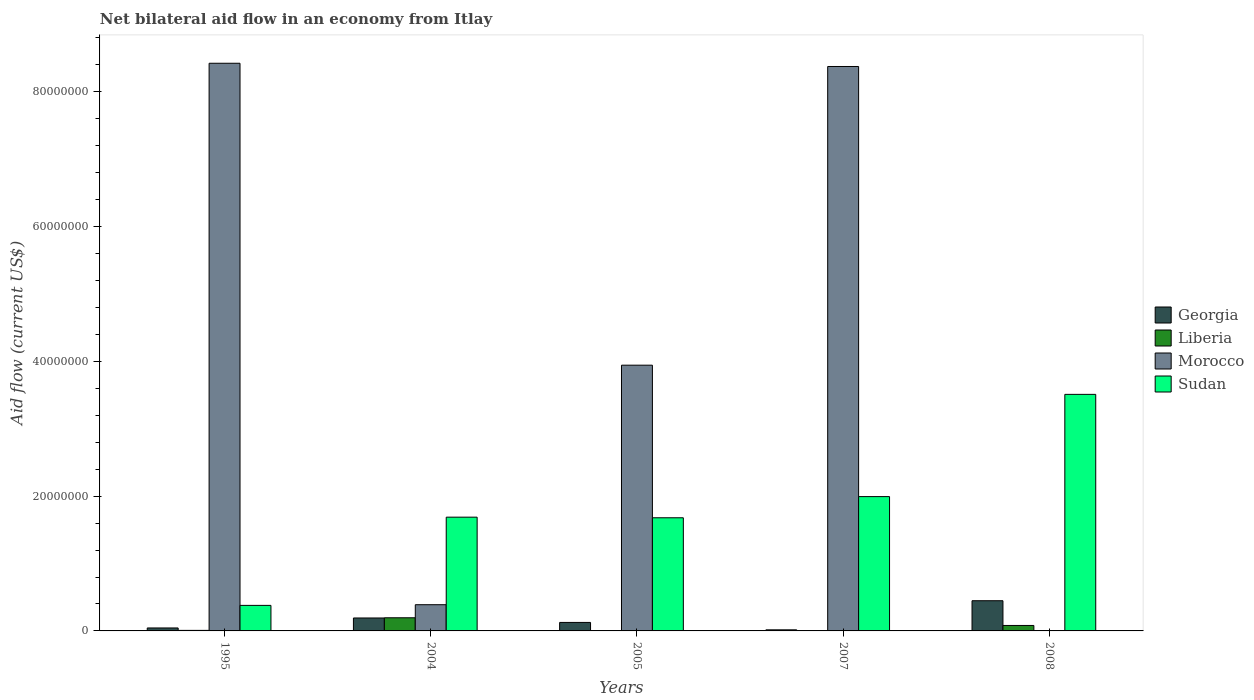How many different coloured bars are there?
Offer a terse response. 4. In how many cases, is the number of bars for a given year not equal to the number of legend labels?
Your response must be concise. 1. What is the net bilateral aid flow in Sudan in 2005?
Make the answer very short. 1.68e+07. Across all years, what is the maximum net bilateral aid flow in Liberia?
Provide a succinct answer. 1.95e+06. In which year was the net bilateral aid flow in Sudan maximum?
Offer a terse response. 2008. What is the total net bilateral aid flow in Georgia in the graph?
Your response must be concise. 8.26e+06. What is the difference between the net bilateral aid flow in Georgia in 2007 and that in 2008?
Your response must be concise. -4.32e+06. What is the difference between the net bilateral aid flow in Liberia in 2007 and the net bilateral aid flow in Morocco in 2005?
Keep it short and to the point. -3.94e+07. What is the average net bilateral aid flow in Sudan per year?
Your answer should be compact. 1.85e+07. In the year 2005, what is the difference between the net bilateral aid flow in Georgia and net bilateral aid flow in Liberia?
Your answer should be very brief. 1.24e+06. What is the ratio of the net bilateral aid flow in Sudan in 1995 to that in 2005?
Your response must be concise. 0.23. Is the net bilateral aid flow in Liberia in 1995 less than that in 2007?
Give a very brief answer. No. What is the difference between the highest and the second highest net bilateral aid flow in Liberia?
Make the answer very short. 1.14e+06. What is the difference between the highest and the lowest net bilateral aid flow in Morocco?
Provide a short and direct response. 8.42e+07. How many bars are there?
Your answer should be very brief. 19. Does the graph contain any zero values?
Ensure brevity in your answer.  Yes. How many legend labels are there?
Your answer should be very brief. 4. How are the legend labels stacked?
Offer a very short reply. Vertical. What is the title of the graph?
Give a very brief answer. Net bilateral aid flow in an economy from Itlay. Does "Small states" appear as one of the legend labels in the graph?
Provide a succinct answer. No. What is the label or title of the X-axis?
Offer a terse response. Years. What is the label or title of the Y-axis?
Give a very brief answer. Aid flow (current US$). What is the Aid flow (current US$) of Morocco in 1995?
Provide a short and direct response. 8.42e+07. What is the Aid flow (current US$) in Sudan in 1995?
Ensure brevity in your answer.  3.79e+06. What is the Aid flow (current US$) of Georgia in 2004?
Offer a very short reply. 1.92e+06. What is the Aid flow (current US$) in Liberia in 2004?
Provide a succinct answer. 1.95e+06. What is the Aid flow (current US$) of Morocco in 2004?
Keep it short and to the point. 3.89e+06. What is the Aid flow (current US$) in Sudan in 2004?
Offer a terse response. 1.69e+07. What is the Aid flow (current US$) of Georgia in 2005?
Give a very brief answer. 1.26e+06. What is the Aid flow (current US$) of Liberia in 2005?
Your answer should be very brief. 2.00e+04. What is the Aid flow (current US$) of Morocco in 2005?
Keep it short and to the point. 3.94e+07. What is the Aid flow (current US$) of Sudan in 2005?
Provide a short and direct response. 1.68e+07. What is the Aid flow (current US$) of Morocco in 2007?
Offer a very short reply. 8.38e+07. What is the Aid flow (current US$) of Sudan in 2007?
Provide a short and direct response. 1.99e+07. What is the Aid flow (current US$) in Georgia in 2008?
Provide a succinct answer. 4.48e+06. What is the Aid flow (current US$) in Liberia in 2008?
Give a very brief answer. 8.10e+05. What is the Aid flow (current US$) of Sudan in 2008?
Make the answer very short. 3.51e+07. Across all years, what is the maximum Aid flow (current US$) in Georgia?
Your answer should be very brief. 4.48e+06. Across all years, what is the maximum Aid flow (current US$) in Liberia?
Make the answer very short. 1.95e+06. Across all years, what is the maximum Aid flow (current US$) in Morocco?
Keep it short and to the point. 8.42e+07. Across all years, what is the maximum Aid flow (current US$) of Sudan?
Your answer should be compact. 3.51e+07. Across all years, what is the minimum Aid flow (current US$) of Georgia?
Provide a short and direct response. 1.60e+05. Across all years, what is the minimum Aid flow (current US$) of Sudan?
Make the answer very short. 3.79e+06. What is the total Aid flow (current US$) in Georgia in the graph?
Offer a terse response. 8.26e+06. What is the total Aid flow (current US$) in Liberia in the graph?
Provide a succinct answer. 2.87e+06. What is the total Aid flow (current US$) of Morocco in the graph?
Ensure brevity in your answer.  2.11e+08. What is the total Aid flow (current US$) of Sudan in the graph?
Your answer should be very brief. 9.25e+07. What is the difference between the Aid flow (current US$) of Georgia in 1995 and that in 2004?
Ensure brevity in your answer.  -1.48e+06. What is the difference between the Aid flow (current US$) in Liberia in 1995 and that in 2004?
Keep it short and to the point. -1.87e+06. What is the difference between the Aid flow (current US$) in Morocco in 1995 and that in 2004?
Your answer should be very brief. 8.03e+07. What is the difference between the Aid flow (current US$) in Sudan in 1995 and that in 2004?
Offer a very short reply. -1.31e+07. What is the difference between the Aid flow (current US$) of Georgia in 1995 and that in 2005?
Give a very brief answer. -8.20e+05. What is the difference between the Aid flow (current US$) in Morocco in 1995 and that in 2005?
Your response must be concise. 4.48e+07. What is the difference between the Aid flow (current US$) in Sudan in 1995 and that in 2005?
Offer a terse response. -1.30e+07. What is the difference between the Aid flow (current US$) of Liberia in 1995 and that in 2007?
Ensure brevity in your answer.  7.00e+04. What is the difference between the Aid flow (current US$) of Sudan in 1995 and that in 2007?
Keep it short and to the point. -1.61e+07. What is the difference between the Aid flow (current US$) in Georgia in 1995 and that in 2008?
Keep it short and to the point. -4.04e+06. What is the difference between the Aid flow (current US$) in Liberia in 1995 and that in 2008?
Keep it short and to the point. -7.30e+05. What is the difference between the Aid flow (current US$) in Sudan in 1995 and that in 2008?
Provide a short and direct response. -3.13e+07. What is the difference between the Aid flow (current US$) in Georgia in 2004 and that in 2005?
Your answer should be very brief. 6.60e+05. What is the difference between the Aid flow (current US$) of Liberia in 2004 and that in 2005?
Give a very brief answer. 1.93e+06. What is the difference between the Aid flow (current US$) of Morocco in 2004 and that in 2005?
Your answer should be very brief. -3.55e+07. What is the difference between the Aid flow (current US$) of Sudan in 2004 and that in 2005?
Provide a succinct answer. 9.00e+04. What is the difference between the Aid flow (current US$) of Georgia in 2004 and that in 2007?
Provide a short and direct response. 1.76e+06. What is the difference between the Aid flow (current US$) of Liberia in 2004 and that in 2007?
Offer a terse response. 1.94e+06. What is the difference between the Aid flow (current US$) in Morocco in 2004 and that in 2007?
Offer a terse response. -7.99e+07. What is the difference between the Aid flow (current US$) of Sudan in 2004 and that in 2007?
Provide a short and direct response. -3.05e+06. What is the difference between the Aid flow (current US$) in Georgia in 2004 and that in 2008?
Provide a succinct answer. -2.56e+06. What is the difference between the Aid flow (current US$) in Liberia in 2004 and that in 2008?
Ensure brevity in your answer.  1.14e+06. What is the difference between the Aid flow (current US$) in Sudan in 2004 and that in 2008?
Make the answer very short. -1.82e+07. What is the difference between the Aid flow (current US$) in Georgia in 2005 and that in 2007?
Your answer should be compact. 1.10e+06. What is the difference between the Aid flow (current US$) in Liberia in 2005 and that in 2007?
Ensure brevity in your answer.  10000. What is the difference between the Aid flow (current US$) in Morocco in 2005 and that in 2007?
Keep it short and to the point. -4.43e+07. What is the difference between the Aid flow (current US$) in Sudan in 2005 and that in 2007?
Your response must be concise. -3.14e+06. What is the difference between the Aid flow (current US$) in Georgia in 2005 and that in 2008?
Keep it short and to the point. -3.22e+06. What is the difference between the Aid flow (current US$) of Liberia in 2005 and that in 2008?
Provide a short and direct response. -7.90e+05. What is the difference between the Aid flow (current US$) in Sudan in 2005 and that in 2008?
Provide a succinct answer. -1.83e+07. What is the difference between the Aid flow (current US$) in Georgia in 2007 and that in 2008?
Provide a short and direct response. -4.32e+06. What is the difference between the Aid flow (current US$) in Liberia in 2007 and that in 2008?
Make the answer very short. -8.00e+05. What is the difference between the Aid flow (current US$) in Sudan in 2007 and that in 2008?
Provide a succinct answer. -1.52e+07. What is the difference between the Aid flow (current US$) of Georgia in 1995 and the Aid flow (current US$) of Liberia in 2004?
Your answer should be very brief. -1.51e+06. What is the difference between the Aid flow (current US$) in Georgia in 1995 and the Aid flow (current US$) in Morocco in 2004?
Offer a terse response. -3.45e+06. What is the difference between the Aid flow (current US$) of Georgia in 1995 and the Aid flow (current US$) of Sudan in 2004?
Give a very brief answer. -1.64e+07. What is the difference between the Aid flow (current US$) in Liberia in 1995 and the Aid flow (current US$) in Morocco in 2004?
Offer a terse response. -3.81e+06. What is the difference between the Aid flow (current US$) of Liberia in 1995 and the Aid flow (current US$) of Sudan in 2004?
Offer a very short reply. -1.68e+07. What is the difference between the Aid flow (current US$) of Morocco in 1995 and the Aid flow (current US$) of Sudan in 2004?
Your response must be concise. 6.74e+07. What is the difference between the Aid flow (current US$) in Georgia in 1995 and the Aid flow (current US$) in Liberia in 2005?
Your answer should be very brief. 4.20e+05. What is the difference between the Aid flow (current US$) in Georgia in 1995 and the Aid flow (current US$) in Morocco in 2005?
Provide a succinct answer. -3.90e+07. What is the difference between the Aid flow (current US$) in Georgia in 1995 and the Aid flow (current US$) in Sudan in 2005?
Keep it short and to the point. -1.64e+07. What is the difference between the Aid flow (current US$) of Liberia in 1995 and the Aid flow (current US$) of Morocco in 2005?
Make the answer very short. -3.94e+07. What is the difference between the Aid flow (current US$) in Liberia in 1995 and the Aid flow (current US$) in Sudan in 2005?
Give a very brief answer. -1.67e+07. What is the difference between the Aid flow (current US$) of Morocco in 1995 and the Aid flow (current US$) of Sudan in 2005?
Your answer should be compact. 6.74e+07. What is the difference between the Aid flow (current US$) of Georgia in 1995 and the Aid flow (current US$) of Liberia in 2007?
Keep it short and to the point. 4.30e+05. What is the difference between the Aid flow (current US$) in Georgia in 1995 and the Aid flow (current US$) in Morocco in 2007?
Your response must be concise. -8.33e+07. What is the difference between the Aid flow (current US$) in Georgia in 1995 and the Aid flow (current US$) in Sudan in 2007?
Your answer should be compact. -1.95e+07. What is the difference between the Aid flow (current US$) of Liberia in 1995 and the Aid flow (current US$) of Morocco in 2007?
Your answer should be very brief. -8.37e+07. What is the difference between the Aid flow (current US$) in Liberia in 1995 and the Aid flow (current US$) in Sudan in 2007?
Offer a very short reply. -1.98e+07. What is the difference between the Aid flow (current US$) in Morocco in 1995 and the Aid flow (current US$) in Sudan in 2007?
Offer a very short reply. 6.43e+07. What is the difference between the Aid flow (current US$) in Georgia in 1995 and the Aid flow (current US$) in Liberia in 2008?
Offer a very short reply. -3.70e+05. What is the difference between the Aid flow (current US$) of Georgia in 1995 and the Aid flow (current US$) of Sudan in 2008?
Keep it short and to the point. -3.47e+07. What is the difference between the Aid flow (current US$) of Liberia in 1995 and the Aid flow (current US$) of Sudan in 2008?
Offer a terse response. -3.50e+07. What is the difference between the Aid flow (current US$) of Morocco in 1995 and the Aid flow (current US$) of Sudan in 2008?
Your answer should be compact. 4.91e+07. What is the difference between the Aid flow (current US$) in Georgia in 2004 and the Aid flow (current US$) in Liberia in 2005?
Keep it short and to the point. 1.90e+06. What is the difference between the Aid flow (current US$) of Georgia in 2004 and the Aid flow (current US$) of Morocco in 2005?
Provide a short and direct response. -3.75e+07. What is the difference between the Aid flow (current US$) in Georgia in 2004 and the Aid flow (current US$) in Sudan in 2005?
Provide a succinct answer. -1.49e+07. What is the difference between the Aid flow (current US$) of Liberia in 2004 and the Aid flow (current US$) of Morocco in 2005?
Your answer should be compact. -3.75e+07. What is the difference between the Aid flow (current US$) of Liberia in 2004 and the Aid flow (current US$) of Sudan in 2005?
Offer a terse response. -1.48e+07. What is the difference between the Aid flow (current US$) in Morocco in 2004 and the Aid flow (current US$) in Sudan in 2005?
Offer a very short reply. -1.29e+07. What is the difference between the Aid flow (current US$) of Georgia in 2004 and the Aid flow (current US$) of Liberia in 2007?
Your answer should be very brief. 1.91e+06. What is the difference between the Aid flow (current US$) in Georgia in 2004 and the Aid flow (current US$) in Morocco in 2007?
Your answer should be compact. -8.18e+07. What is the difference between the Aid flow (current US$) in Georgia in 2004 and the Aid flow (current US$) in Sudan in 2007?
Your answer should be compact. -1.80e+07. What is the difference between the Aid flow (current US$) of Liberia in 2004 and the Aid flow (current US$) of Morocco in 2007?
Your answer should be very brief. -8.18e+07. What is the difference between the Aid flow (current US$) in Liberia in 2004 and the Aid flow (current US$) in Sudan in 2007?
Give a very brief answer. -1.80e+07. What is the difference between the Aid flow (current US$) in Morocco in 2004 and the Aid flow (current US$) in Sudan in 2007?
Give a very brief answer. -1.60e+07. What is the difference between the Aid flow (current US$) in Georgia in 2004 and the Aid flow (current US$) in Liberia in 2008?
Offer a very short reply. 1.11e+06. What is the difference between the Aid flow (current US$) in Georgia in 2004 and the Aid flow (current US$) in Sudan in 2008?
Your response must be concise. -3.32e+07. What is the difference between the Aid flow (current US$) in Liberia in 2004 and the Aid flow (current US$) in Sudan in 2008?
Offer a very short reply. -3.32e+07. What is the difference between the Aid flow (current US$) of Morocco in 2004 and the Aid flow (current US$) of Sudan in 2008?
Your answer should be very brief. -3.12e+07. What is the difference between the Aid flow (current US$) in Georgia in 2005 and the Aid flow (current US$) in Liberia in 2007?
Offer a very short reply. 1.25e+06. What is the difference between the Aid flow (current US$) in Georgia in 2005 and the Aid flow (current US$) in Morocco in 2007?
Your answer should be compact. -8.25e+07. What is the difference between the Aid flow (current US$) in Georgia in 2005 and the Aid flow (current US$) in Sudan in 2007?
Offer a very short reply. -1.87e+07. What is the difference between the Aid flow (current US$) of Liberia in 2005 and the Aid flow (current US$) of Morocco in 2007?
Ensure brevity in your answer.  -8.37e+07. What is the difference between the Aid flow (current US$) of Liberia in 2005 and the Aid flow (current US$) of Sudan in 2007?
Offer a very short reply. -1.99e+07. What is the difference between the Aid flow (current US$) in Morocco in 2005 and the Aid flow (current US$) in Sudan in 2007?
Your answer should be compact. 1.95e+07. What is the difference between the Aid flow (current US$) in Georgia in 2005 and the Aid flow (current US$) in Sudan in 2008?
Provide a succinct answer. -3.38e+07. What is the difference between the Aid flow (current US$) in Liberia in 2005 and the Aid flow (current US$) in Sudan in 2008?
Offer a terse response. -3.51e+07. What is the difference between the Aid flow (current US$) of Morocco in 2005 and the Aid flow (current US$) of Sudan in 2008?
Make the answer very short. 4.33e+06. What is the difference between the Aid flow (current US$) in Georgia in 2007 and the Aid flow (current US$) in Liberia in 2008?
Provide a succinct answer. -6.50e+05. What is the difference between the Aid flow (current US$) in Georgia in 2007 and the Aid flow (current US$) in Sudan in 2008?
Give a very brief answer. -3.49e+07. What is the difference between the Aid flow (current US$) in Liberia in 2007 and the Aid flow (current US$) in Sudan in 2008?
Your response must be concise. -3.51e+07. What is the difference between the Aid flow (current US$) in Morocco in 2007 and the Aid flow (current US$) in Sudan in 2008?
Keep it short and to the point. 4.86e+07. What is the average Aid flow (current US$) of Georgia per year?
Give a very brief answer. 1.65e+06. What is the average Aid flow (current US$) in Liberia per year?
Ensure brevity in your answer.  5.74e+05. What is the average Aid flow (current US$) in Morocco per year?
Your response must be concise. 4.23e+07. What is the average Aid flow (current US$) in Sudan per year?
Provide a short and direct response. 1.85e+07. In the year 1995, what is the difference between the Aid flow (current US$) in Georgia and Aid flow (current US$) in Morocco?
Provide a short and direct response. -8.38e+07. In the year 1995, what is the difference between the Aid flow (current US$) in Georgia and Aid flow (current US$) in Sudan?
Give a very brief answer. -3.35e+06. In the year 1995, what is the difference between the Aid flow (current US$) in Liberia and Aid flow (current US$) in Morocco?
Give a very brief answer. -8.42e+07. In the year 1995, what is the difference between the Aid flow (current US$) of Liberia and Aid flow (current US$) of Sudan?
Provide a short and direct response. -3.71e+06. In the year 1995, what is the difference between the Aid flow (current US$) of Morocco and Aid flow (current US$) of Sudan?
Your response must be concise. 8.04e+07. In the year 2004, what is the difference between the Aid flow (current US$) in Georgia and Aid flow (current US$) in Liberia?
Make the answer very short. -3.00e+04. In the year 2004, what is the difference between the Aid flow (current US$) in Georgia and Aid flow (current US$) in Morocco?
Provide a succinct answer. -1.97e+06. In the year 2004, what is the difference between the Aid flow (current US$) in Georgia and Aid flow (current US$) in Sudan?
Ensure brevity in your answer.  -1.50e+07. In the year 2004, what is the difference between the Aid flow (current US$) in Liberia and Aid flow (current US$) in Morocco?
Give a very brief answer. -1.94e+06. In the year 2004, what is the difference between the Aid flow (current US$) in Liberia and Aid flow (current US$) in Sudan?
Give a very brief answer. -1.49e+07. In the year 2004, what is the difference between the Aid flow (current US$) of Morocco and Aid flow (current US$) of Sudan?
Your answer should be very brief. -1.30e+07. In the year 2005, what is the difference between the Aid flow (current US$) of Georgia and Aid flow (current US$) of Liberia?
Offer a very short reply. 1.24e+06. In the year 2005, what is the difference between the Aid flow (current US$) in Georgia and Aid flow (current US$) in Morocco?
Keep it short and to the point. -3.82e+07. In the year 2005, what is the difference between the Aid flow (current US$) of Georgia and Aid flow (current US$) of Sudan?
Offer a terse response. -1.55e+07. In the year 2005, what is the difference between the Aid flow (current US$) of Liberia and Aid flow (current US$) of Morocco?
Offer a very short reply. -3.94e+07. In the year 2005, what is the difference between the Aid flow (current US$) in Liberia and Aid flow (current US$) in Sudan?
Offer a terse response. -1.68e+07. In the year 2005, what is the difference between the Aid flow (current US$) in Morocco and Aid flow (current US$) in Sudan?
Provide a succinct answer. 2.26e+07. In the year 2007, what is the difference between the Aid flow (current US$) in Georgia and Aid flow (current US$) in Liberia?
Provide a short and direct response. 1.50e+05. In the year 2007, what is the difference between the Aid flow (current US$) in Georgia and Aid flow (current US$) in Morocco?
Your answer should be very brief. -8.36e+07. In the year 2007, what is the difference between the Aid flow (current US$) in Georgia and Aid flow (current US$) in Sudan?
Offer a terse response. -1.98e+07. In the year 2007, what is the difference between the Aid flow (current US$) in Liberia and Aid flow (current US$) in Morocco?
Your answer should be compact. -8.37e+07. In the year 2007, what is the difference between the Aid flow (current US$) in Liberia and Aid flow (current US$) in Sudan?
Your answer should be very brief. -1.99e+07. In the year 2007, what is the difference between the Aid flow (current US$) of Morocco and Aid flow (current US$) of Sudan?
Your response must be concise. 6.38e+07. In the year 2008, what is the difference between the Aid flow (current US$) in Georgia and Aid flow (current US$) in Liberia?
Make the answer very short. 3.67e+06. In the year 2008, what is the difference between the Aid flow (current US$) of Georgia and Aid flow (current US$) of Sudan?
Offer a very short reply. -3.06e+07. In the year 2008, what is the difference between the Aid flow (current US$) in Liberia and Aid flow (current US$) in Sudan?
Your response must be concise. -3.43e+07. What is the ratio of the Aid flow (current US$) of Georgia in 1995 to that in 2004?
Your answer should be compact. 0.23. What is the ratio of the Aid flow (current US$) in Liberia in 1995 to that in 2004?
Make the answer very short. 0.04. What is the ratio of the Aid flow (current US$) of Morocco in 1995 to that in 2004?
Offer a terse response. 21.65. What is the ratio of the Aid flow (current US$) in Sudan in 1995 to that in 2004?
Give a very brief answer. 0.22. What is the ratio of the Aid flow (current US$) of Georgia in 1995 to that in 2005?
Offer a very short reply. 0.35. What is the ratio of the Aid flow (current US$) in Liberia in 1995 to that in 2005?
Your answer should be compact. 4. What is the ratio of the Aid flow (current US$) in Morocco in 1995 to that in 2005?
Your response must be concise. 2.14. What is the ratio of the Aid flow (current US$) of Sudan in 1995 to that in 2005?
Offer a very short reply. 0.23. What is the ratio of the Aid flow (current US$) in Georgia in 1995 to that in 2007?
Offer a terse response. 2.75. What is the ratio of the Aid flow (current US$) of Morocco in 1995 to that in 2007?
Offer a very short reply. 1.01. What is the ratio of the Aid flow (current US$) of Sudan in 1995 to that in 2007?
Keep it short and to the point. 0.19. What is the ratio of the Aid flow (current US$) of Georgia in 1995 to that in 2008?
Keep it short and to the point. 0.1. What is the ratio of the Aid flow (current US$) in Liberia in 1995 to that in 2008?
Make the answer very short. 0.1. What is the ratio of the Aid flow (current US$) of Sudan in 1995 to that in 2008?
Your answer should be very brief. 0.11. What is the ratio of the Aid flow (current US$) in Georgia in 2004 to that in 2005?
Offer a very short reply. 1.52. What is the ratio of the Aid flow (current US$) of Liberia in 2004 to that in 2005?
Your answer should be compact. 97.5. What is the ratio of the Aid flow (current US$) of Morocco in 2004 to that in 2005?
Make the answer very short. 0.1. What is the ratio of the Aid flow (current US$) in Sudan in 2004 to that in 2005?
Your answer should be compact. 1.01. What is the ratio of the Aid flow (current US$) in Georgia in 2004 to that in 2007?
Keep it short and to the point. 12. What is the ratio of the Aid flow (current US$) of Liberia in 2004 to that in 2007?
Make the answer very short. 195. What is the ratio of the Aid flow (current US$) in Morocco in 2004 to that in 2007?
Your response must be concise. 0.05. What is the ratio of the Aid flow (current US$) in Sudan in 2004 to that in 2007?
Provide a short and direct response. 0.85. What is the ratio of the Aid flow (current US$) of Georgia in 2004 to that in 2008?
Your answer should be compact. 0.43. What is the ratio of the Aid flow (current US$) of Liberia in 2004 to that in 2008?
Provide a short and direct response. 2.41. What is the ratio of the Aid flow (current US$) in Sudan in 2004 to that in 2008?
Your response must be concise. 0.48. What is the ratio of the Aid flow (current US$) of Georgia in 2005 to that in 2007?
Provide a short and direct response. 7.88. What is the ratio of the Aid flow (current US$) of Morocco in 2005 to that in 2007?
Your response must be concise. 0.47. What is the ratio of the Aid flow (current US$) in Sudan in 2005 to that in 2007?
Provide a short and direct response. 0.84. What is the ratio of the Aid flow (current US$) of Georgia in 2005 to that in 2008?
Give a very brief answer. 0.28. What is the ratio of the Aid flow (current US$) in Liberia in 2005 to that in 2008?
Ensure brevity in your answer.  0.02. What is the ratio of the Aid flow (current US$) in Sudan in 2005 to that in 2008?
Offer a very short reply. 0.48. What is the ratio of the Aid flow (current US$) of Georgia in 2007 to that in 2008?
Your answer should be very brief. 0.04. What is the ratio of the Aid flow (current US$) in Liberia in 2007 to that in 2008?
Give a very brief answer. 0.01. What is the ratio of the Aid flow (current US$) of Sudan in 2007 to that in 2008?
Provide a short and direct response. 0.57. What is the difference between the highest and the second highest Aid flow (current US$) of Georgia?
Keep it short and to the point. 2.56e+06. What is the difference between the highest and the second highest Aid flow (current US$) of Liberia?
Give a very brief answer. 1.14e+06. What is the difference between the highest and the second highest Aid flow (current US$) in Sudan?
Give a very brief answer. 1.52e+07. What is the difference between the highest and the lowest Aid flow (current US$) of Georgia?
Your answer should be compact. 4.32e+06. What is the difference between the highest and the lowest Aid flow (current US$) of Liberia?
Your answer should be very brief. 1.94e+06. What is the difference between the highest and the lowest Aid flow (current US$) of Morocco?
Provide a succinct answer. 8.42e+07. What is the difference between the highest and the lowest Aid flow (current US$) in Sudan?
Your response must be concise. 3.13e+07. 